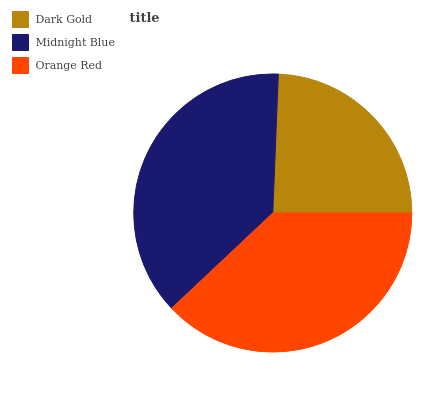Is Dark Gold the minimum?
Answer yes or no. Yes. Is Orange Red the maximum?
Answer yes or no. Yes. Is Midnight Blue the minimum?
Answer yes or no. No. Is Midnight Blue the maximum?
Answer yes or no. No. Is Midnight Blue greater than Dark Gold?
Answer yes or no. Yes. Is Dark Gold less than Midnight Blue?
Answer yes or no. Yes. Is Dark Gold greater than Midnight Blue?
Answer yes or no. No. Is Midnight Blue less than Dark Gold?
Answer yes or no. No. Is Midnight Blue the high median?
Answer yes or no. Yes. Is Midnight Blue the low median?
Answer yes or no. Yes. Is Dark Gold the high median?
Answer yes or no. No. Is Orange Red the low median?
Answer yes or no. No. 